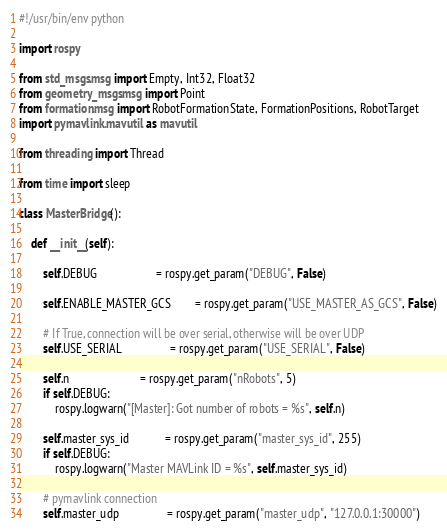<code> <loc_0><loc_0><loc_500><loc_500><_Python_>#!/usr/bin/env python

import rospy

from std_msgs.msg import Empty, Int32, Float32
from geometry_msgs.msg import Point
from formation.msg import RobotFormationState, FormationPositions, RobotTarget
import pymavlink.mavutil as mavutil

from threading import Thread

from time import sleep

class MasterBridge():

	def __init__(self):

		self.DEBUG					= rospy.get_param("DEBUG", False)

		self.ENABLE_MASTER_GCS		= rospy.get_param("USE_MASTER_AS_GCS", False)

		# If True, connection will be over serial, otherwise will be over UDP
		self.USE_SERIAL				= rospy.get_param("USE_SERIAL", False)
		
		self.n 						= rospy.get_param("nRobots", 5)
		if self.DEBUG:
			rospy.logwarn("[Master]: Got number of robots = %s", self.n)

		self.master_sys_id			= rospy.get_param("master_sys_id", 255)
		if self.DEBUG:
			rospy.logwarn("Master MAVLink ID = %s", self.master_sys_id)

		# pymavlink connection
		self.master_udp				= rospy.get_param("master_udp", "127.0.0.1:30000")</code> 